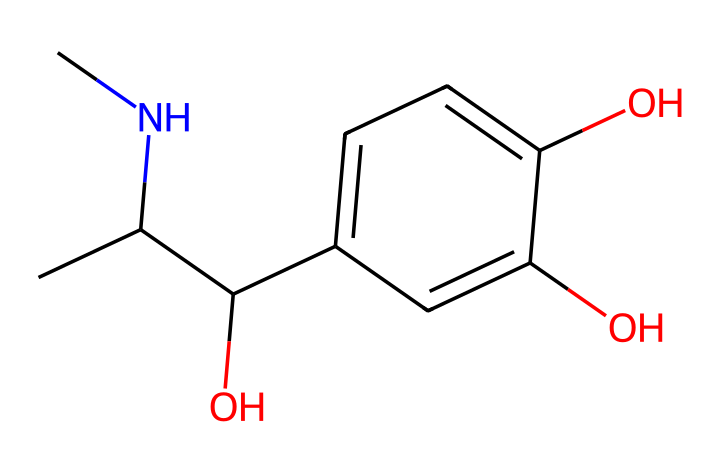What is the molecular formula of adrenaline? To determine the molecular formula, count the number of each type of atom in the SMILES representation. The SMILES indicates 9 carbon atoms (C), 13 hydrogen atoms (H), 1 nitrogen atom (N), and 3 oxygen atoms (O). Therefore, the molecular formula is C9H13N3O3.
Answer: C9H13N3O3 How many hydroxyl (-OH) groups are present in adrenaline? In the chemical structure represented by the SMILES, the hydroxyl groups are indicated by the 'O' next to carbon atoms. By analyzing the structure, we see that there are 3 hydroxyl groups attached to different carbon atoms.
Answer: 3 What type of hormone is adrenaline classified as? Adrenaline is classified as a catecholamine hormone. This classification is based on its structure which contains a catechol group (a benzene ring with two hydroxyl groups) and an amine group.
Answer: catecholamine Which functional group is responsible for the basic amine characteristics of adrenaline? The amine group is indicated by the nitrogen atom (N) in the structure, which is attached to the carbon backbone. This nitrogen atom contributes to the basic characteristics of the molecule.
Answer: amine What is the total number of rings in the chemical structure of adrenaline? From the SMILES representation, we can identify that adrenaline has a single benzene ring in its structure, which introduces the aromatic properties and contributes to its reactivity.
Answer: 1 How many carbon atoms are in the aliphatic chain of adrenaline? By analyzing the SMILES representation, we can identify the straight chain connected to the aromatic ring that consists of 5 carbon atoms (C), indicating the length of the aliphatic portion of the molecule.
Answer: 5 